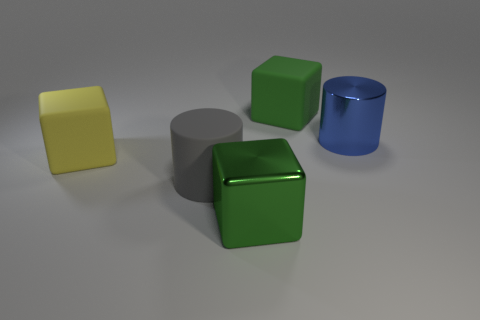Does the material of each object look different? Yes, the materials vary among the objects. The yellow block looks matte and solid, possibly plastic, the grey cylinder has a matte finish which could imply a metallic or stoneware texture, the green cube appears to be rubber due to its shiny and slightly bumpy surface, and the blue cylinder looks glossy, suggesting a metallic or ceramic material. 